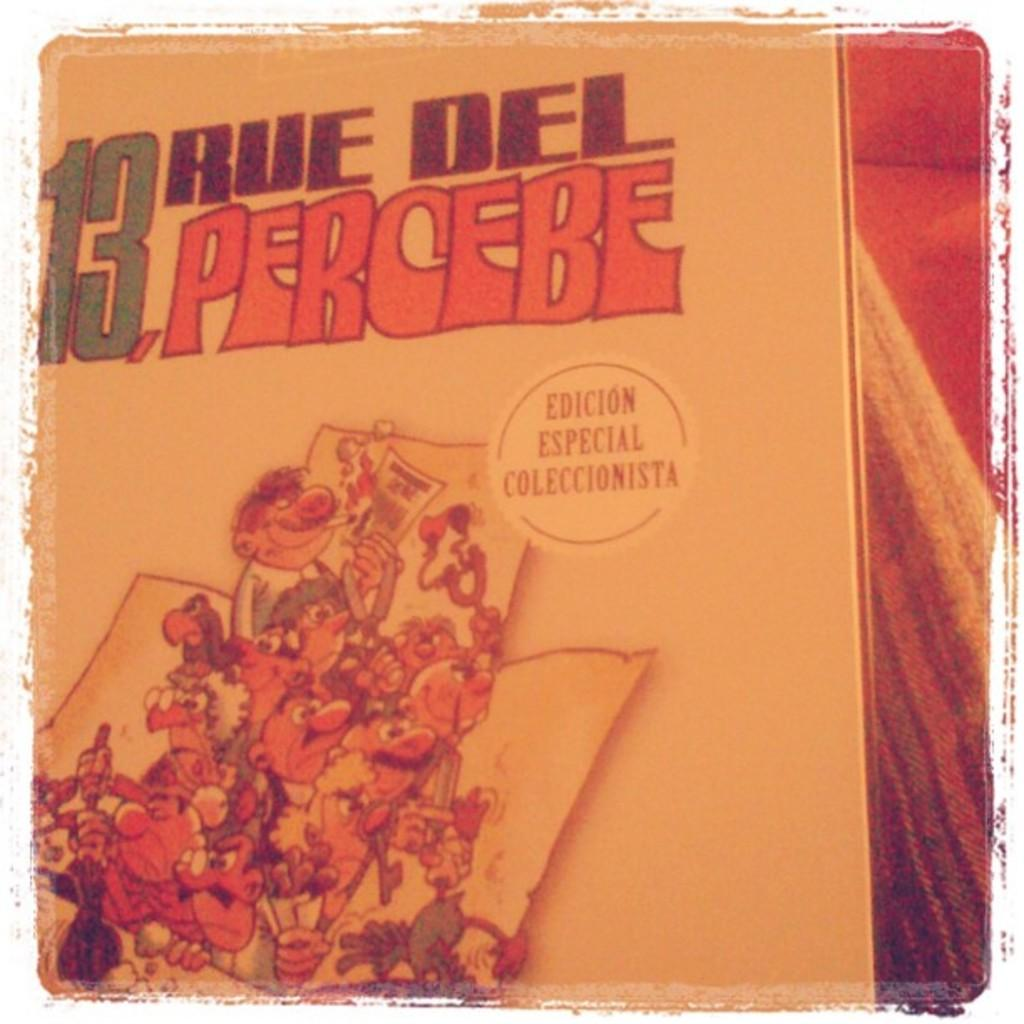<image>
Offer a succinct explanation of the picture presented. 13 rue del percebe edicion especial coleccionista wrote in spanish on a book 